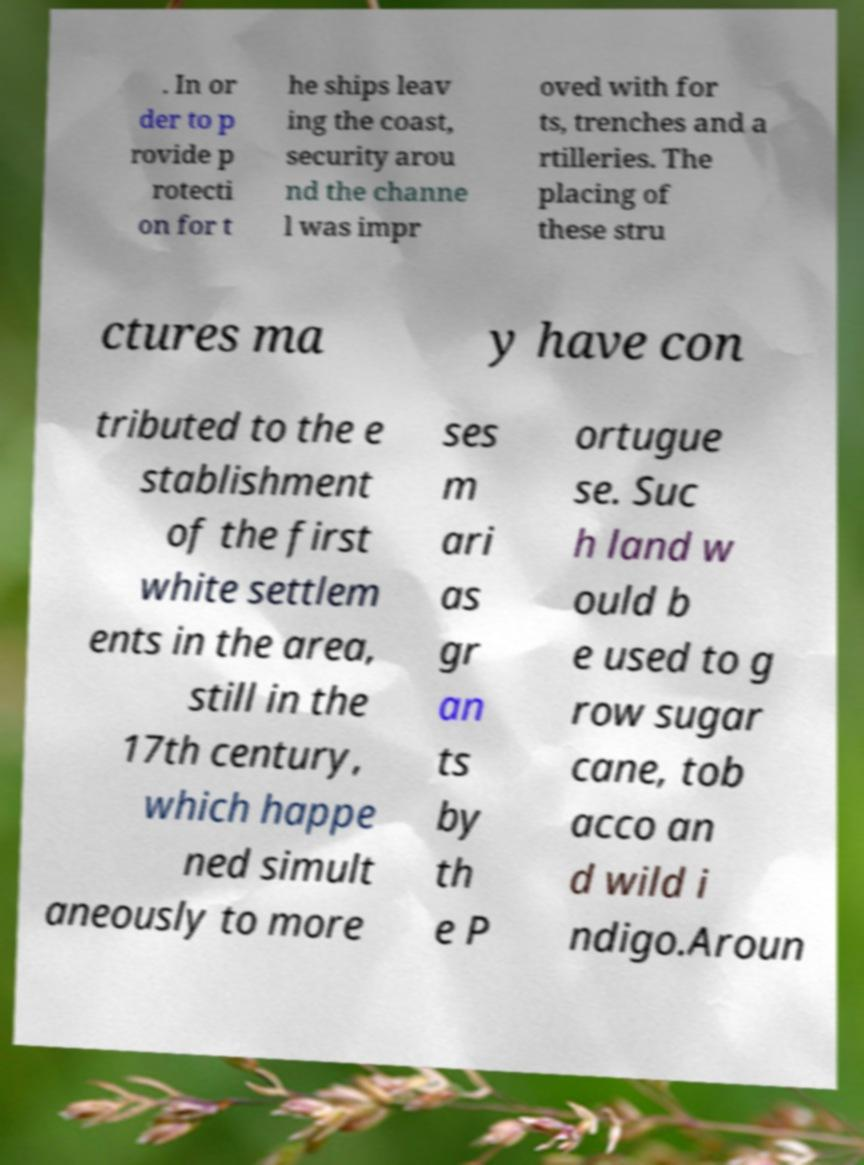There's text embedded in this image that I need extracted. Can you transcribe it verbatim? . In or der to p rovide p rotecti on for t he ships leav ing the coast, security arou nd the channe l was impr oved with for ts, trenches and a rtilleries. The placing of these stru ctures ma y have con tributed to the e stablishment of the first white settlem ents in the area, still in the 17th century, which happe ned simult aneously to more ses m ari as gr an ts by th e P ortugue se. Suc h land w ould b e used to g row sugar cane, tob acco an d wild i ndigo.Aroun 